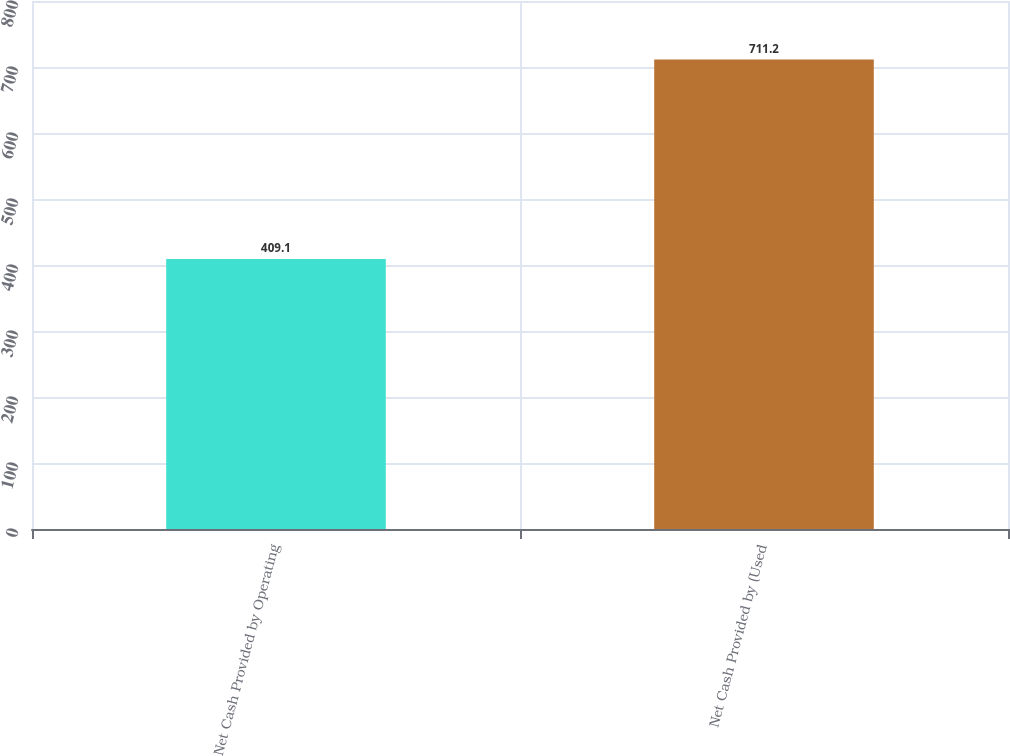<chart> <loc_0><loc_0><loc_500><loc_500><bar_chart><fcel>Net Cash Provided by Operating<fcel>Net Cash Provided by (Used<nl><fcel>409.1<fcel>711.2<nl></chart> 